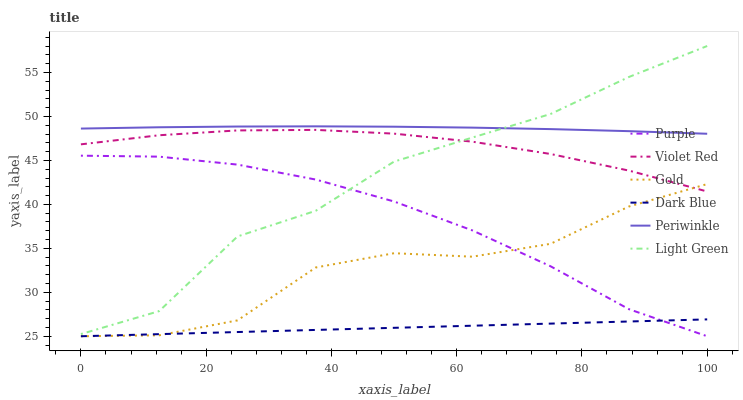Does Dark Blue have the minimum area under the curve?
Answer yes or no. Yes. Does Periwinkle have the maximum area under the curve?
Answer yes or no. Yes. Does Gold have the minimum area under the curve?
Answer yes or no. No. Does Gold have the maximum area under the curve?
Answer yes or no. No. Is Dark Blue the smoothest?
Answer yes or no. Yes. Is Light Green the roughest?
Answer yes or no. Yes. Is Gold the smoothest?
Answer yes or no. No. Is Gold the roughest?
Answer yes or no. No. Does Periwinkle have the lowest value?
Answer yes or no. No. Does Gold have the highest value?
Answer yes or no. No. Is Dark Blue less than Periwinkle?
Answer yes or no. Yes. Is Periwinkle greater than Dark Blue?
Answer yes or no. Yes. Does Dark Blue intersect Periwinkle?
Answer yes or no. No. 